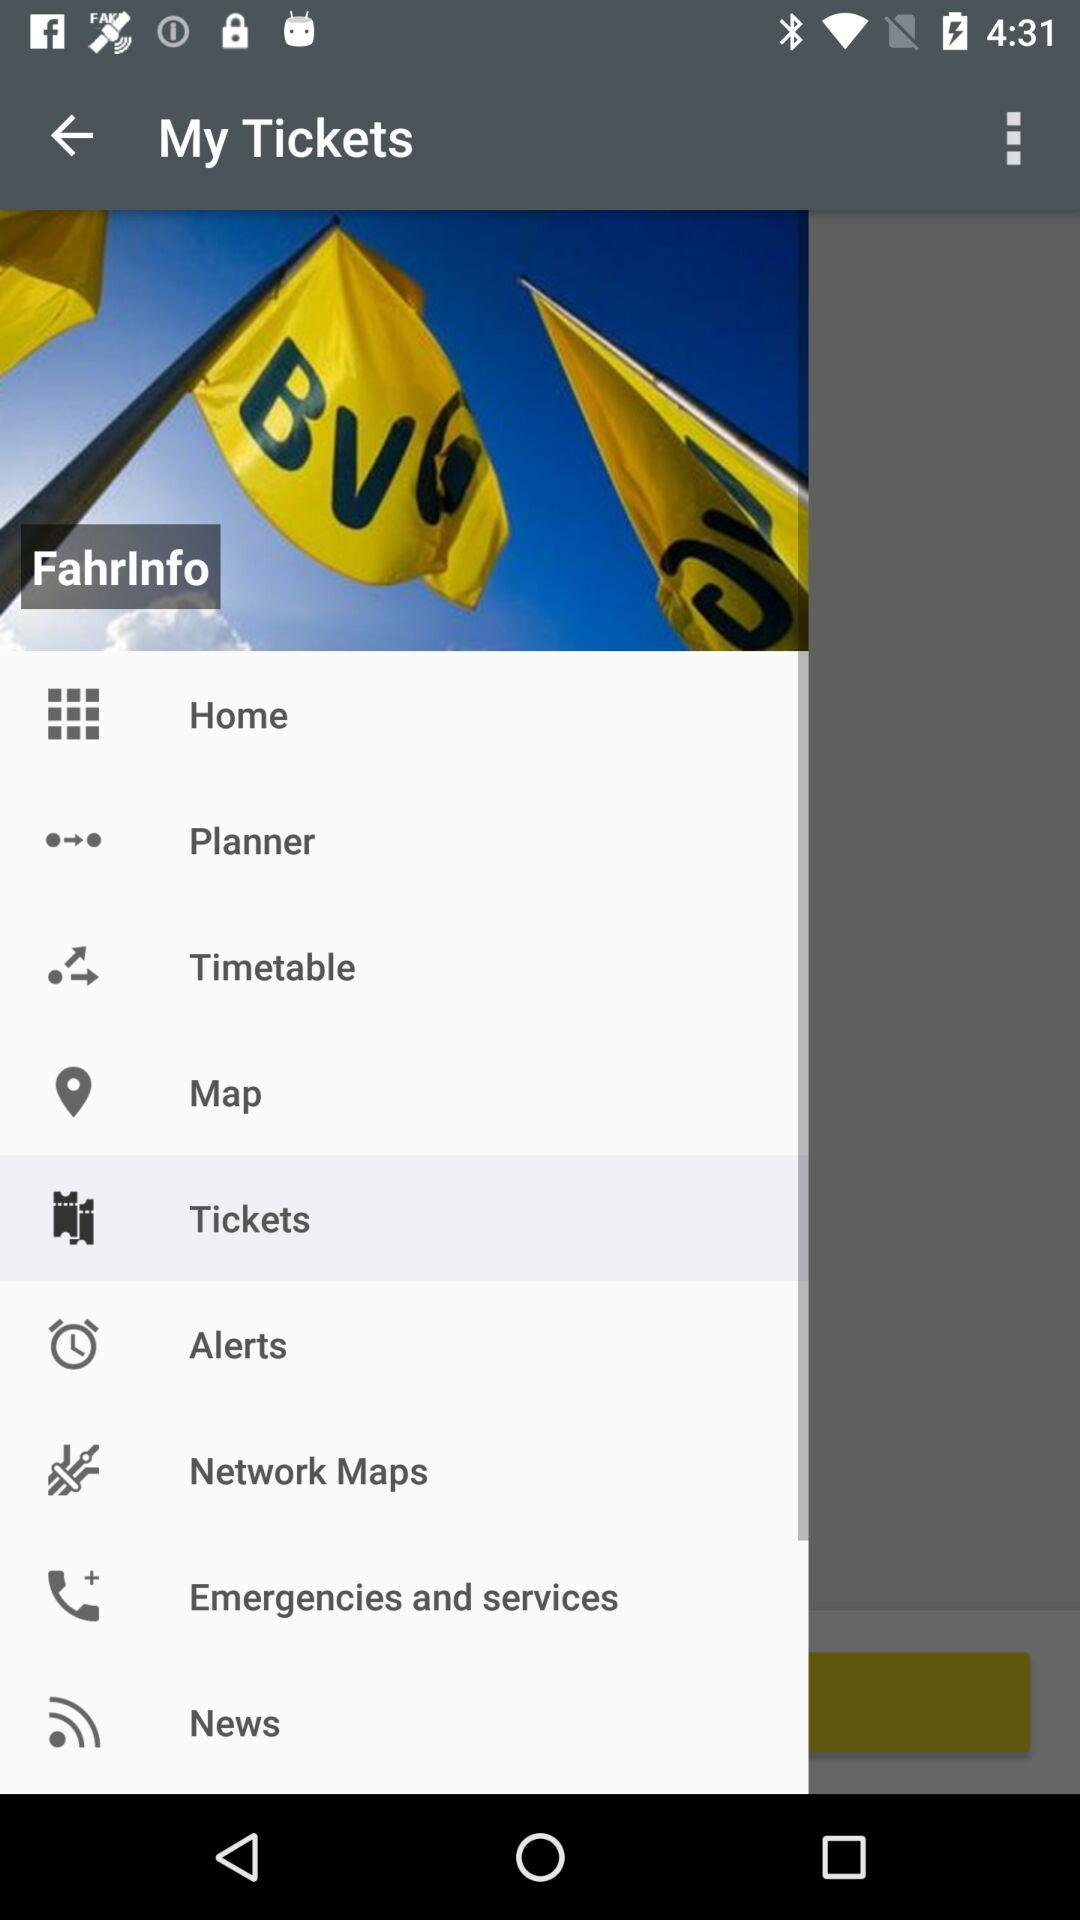What option is selected? The selected option is "Tickets". 